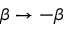Convert formula to latex. <formula><loc_0><loc_0><loc_500><loc_500>\beta \rightarrow - \beta</formula> 